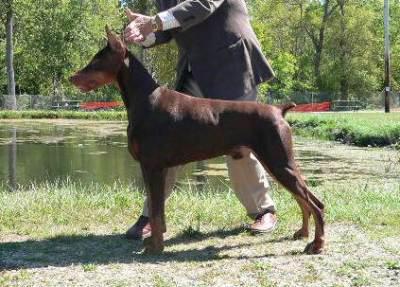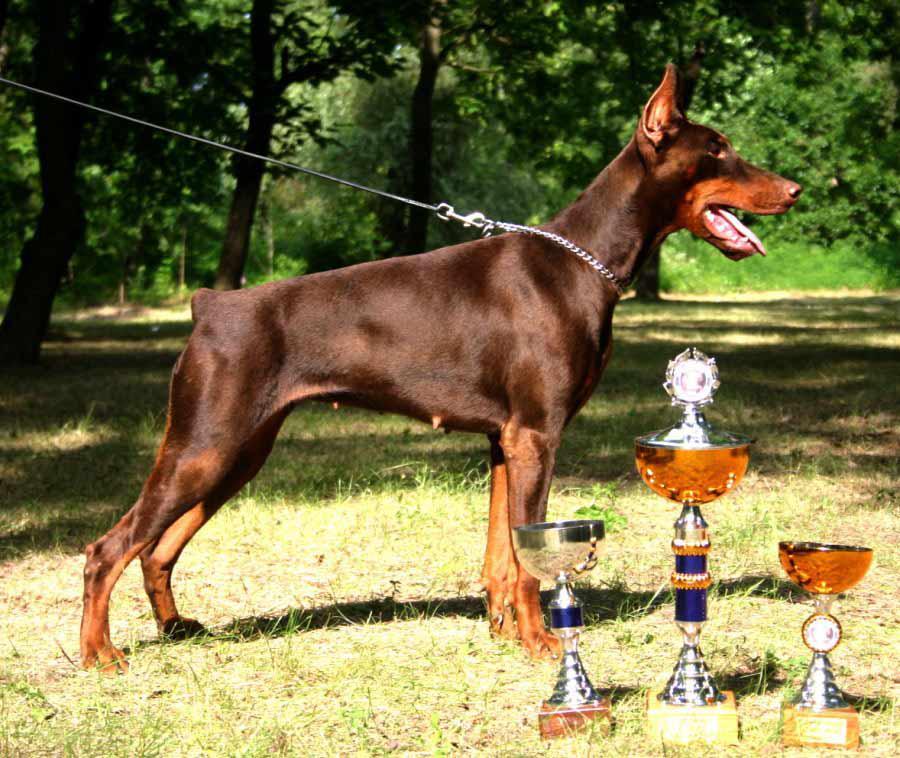The first image is the image on the left, the second image is the image on the right. Assess this claim about the two images: "there is a doberman wearing a silver chain collar". Correct or not? Answer yes or no. Yes. The first image is the image on the left, the second image is the image on the right. Considering the images on both sides, is "The left image contains a left-facing dock-tailed dog standing in profile, with a handler behind it, and the right image contains one erect-eared dog wearing a chain collar." valid? Answer yes or no. Yes. 